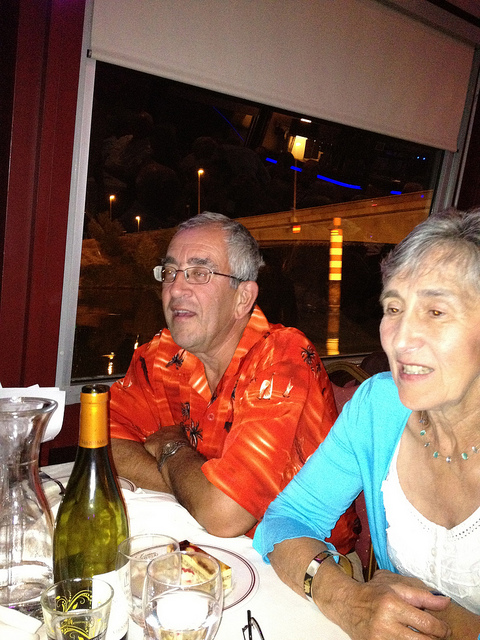If this image were part of a movie scene, what might be happening? In the context of a movie scene, this image might depict a warm and intimate dinner shared between family members or close friends. The older gentleman in the orange Hawaiian shirt could be telling a humorous or heartfelt story, as the woman listens attentively, possibly leading to a touching or enlightening moment in the plot. What could be the backstory of the characters in this image? The older gentleman in the orange Hawaiian shirt might be a retired sailor who loves to share his adventures from the sea. The woman beside him could be his lifelong partner, supporting him through all his journeys. They are now enjoying their golden years, traveling and reliving their memories. 